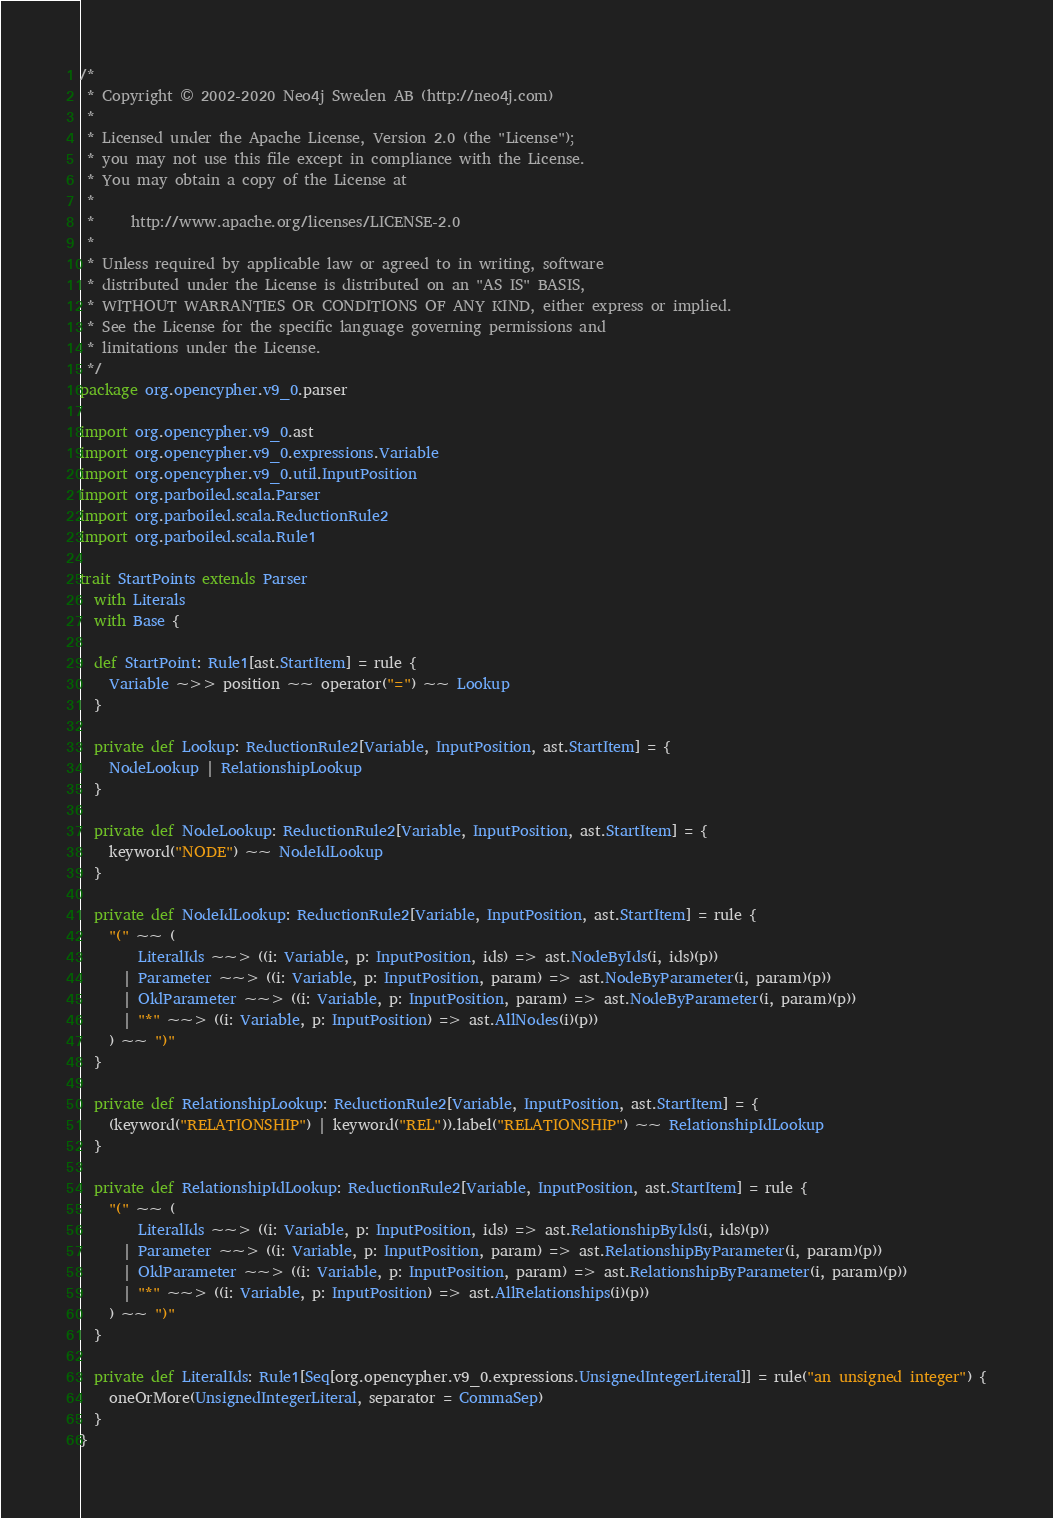Convert code to text. <code><loc_0><loc_0><loc_500><loc_500><_Scala_>/*
 * Copyright © 2002-2020 Neo4j Sweden AB (http://neo4j.com)
 *
 * Licensed under the Apache License, Version 2.0 (the "License");
 * you may not use this file except in compliance with the License.
 * You may obtain a copy of the License at
 *
 *     http://www.apache.org/licenses/LICENSE-2.0
 *
 * Unless required by applicable law or agreed to in writing, software
 * distributed under the License is distributed on an "AS IS" BASIS,
 * WITHOUT WARRANTIES OR CONDITIONS OF ANY KIND, either express or implied.
 * See the License for the specific language governing permissions and
 * limitations under the License.
 */
package org.opencypher.v9_0.parser

import org.opencypher.v9_0.ast
import org.opencypher.v9_0.expressions.Variable
import org.opencypher.v9_0.util.InputPosition
import org.parboiled.scala.Parser
import org.parboiled.scala.ReductionRule2
import org.parboiled.scala.Rule1

trait StartPoints extends Parser
  with Literals
  with Base {

  def StartPoint: Rule1[ast.StartItem] = rule {
    Variable ~>> position ~~ operator("=") ~~ Lookup
  }

  private def Lookup: ReductionRule2[Variable, InputPosition, ast.StartItem] = {
    NodeLookup | RelationshipLookup
  }

  private def NodeLookup: ReductionRule2[Variable, InputPosition, ast.StartItem] = {
    keyword("NODE") ~~ NodeIdLookup
  }

  private def NodeIdLookup: ReductionRule2[Variable, InputPosition, ast.StartItem] = rule {
    "(" ~~ (
        LiteralIds ~~> ((i: Variable, p: InputPosition, ids) => ast.NodeByIds(i, ids)(p))
      | Parameter ~~> ((i: Variable, p: InputPosition, param) => ast.NodeByParameter(i, param)(p))
      | OldParameter ~~> ((i: Variable, p: InputPosition, param) => ast.NodeByParameter(i, param)(p))
      | "*" ~~> ((i: Variable, p: InputPosition) => ast.AllNodes(i)(p))
    ) ~~ ")"
  }

  private def RelationshipLookup: ReductionRule2[Variable, InputPosition, ast.StartItem] = {
    (keyword("RELATIONSHIP") | keyword("REL")).label("RELATIONSHIP") ~~ RelationshipIdLookup
  }

  private def RelationshipIdLookup: ReductionRule2[Variable, InputPosition, ast.StartItem] = rule {
    "(" ~~ (
        LiteralIds ~~> ((i: Variable, p: InputPosition, ids) => ast.RelationshipByIds(i, ids)(p))
      | Parameter ~~> ((i: Variable, p: InputPosition, param) => ast.RelationshipByParameter(i, param)(p))
      | OldParameter ~~> ((i: Variable, p: InputPosition, param) => ast.RelationshipByParameter(i, param)(p))
      | "*" ~~> ((i: Variable, p: InputPosition) => ast.AllRelationships(i)(p))
    ) ~~ ")"
  }

  private def LiteralIds: Rule1[Seq[org.opencypher.v9_0.expressions.UnsignedIntegerLiteral]] = rule("an unsigned integer") {
    oneOrMore(UnsignedIntegerLiteral, separator = CommaSep)
  }
}
</code> 